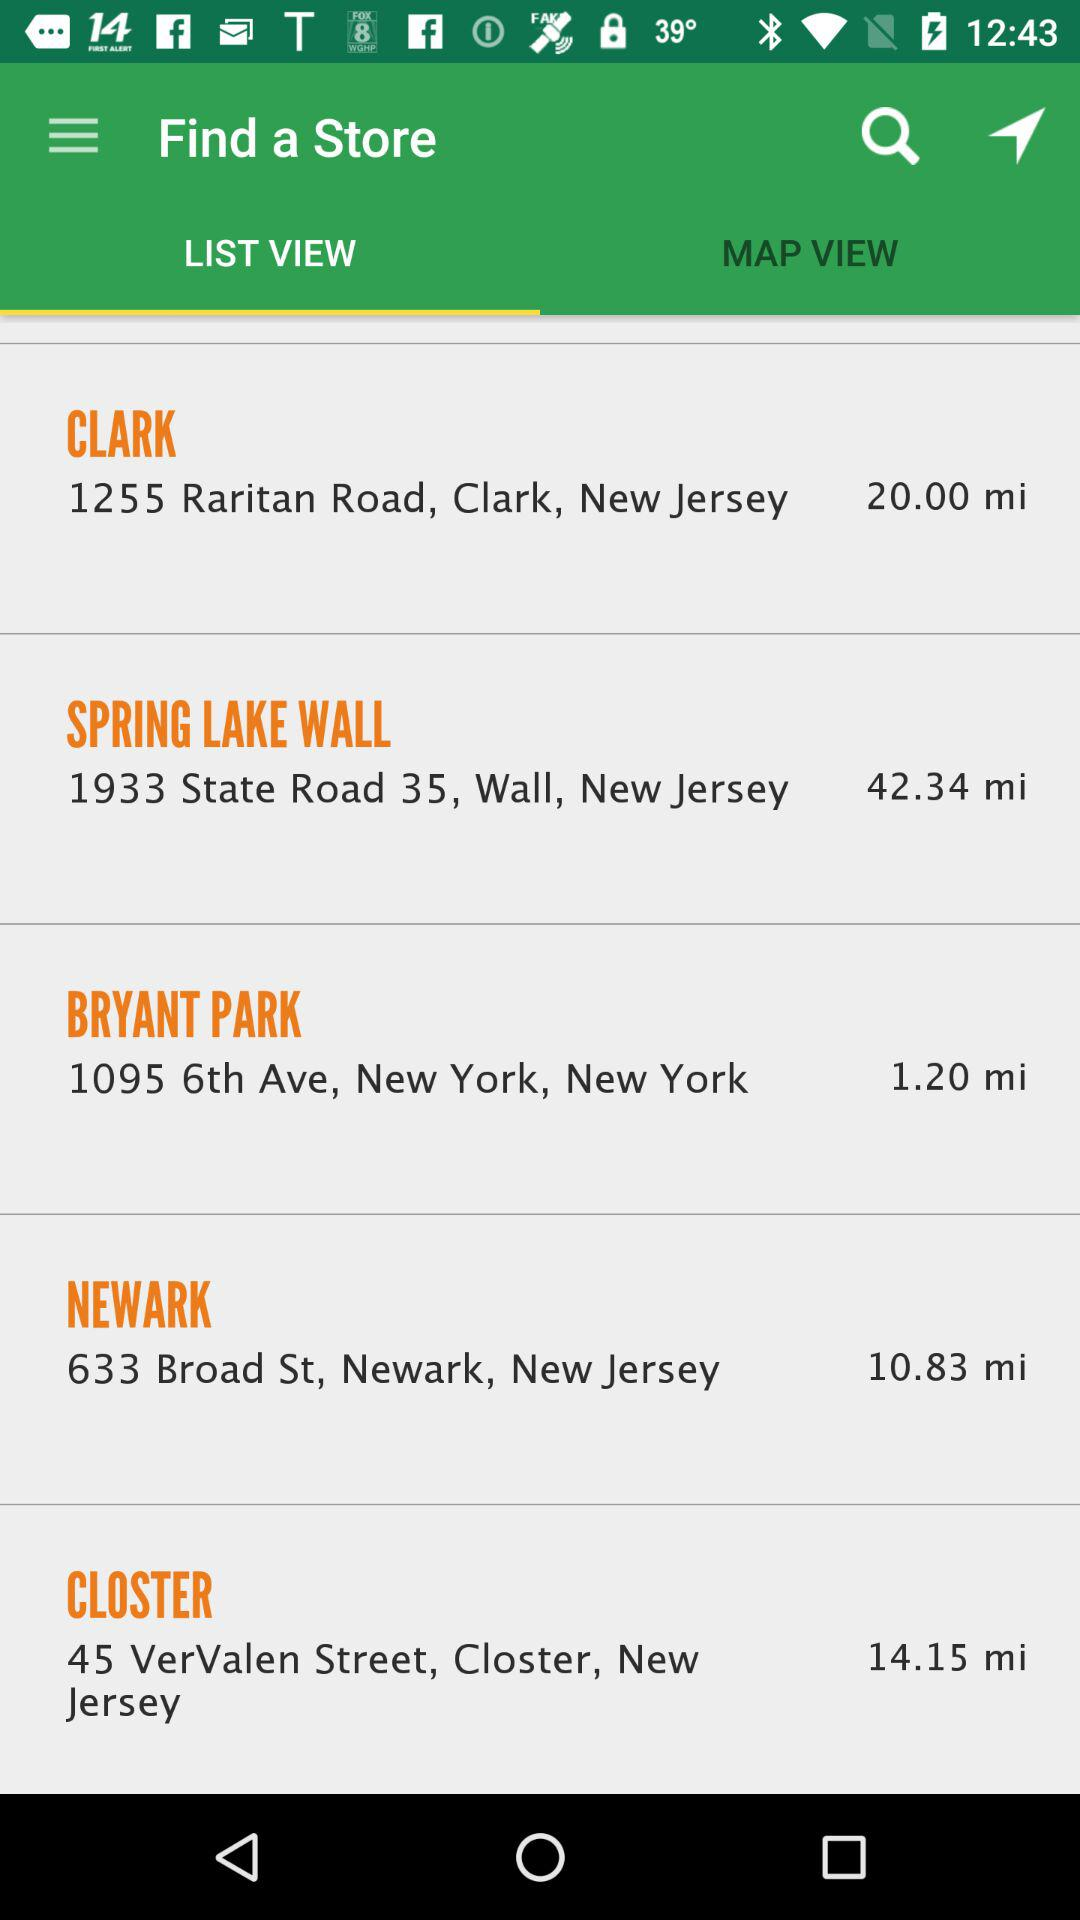Which are the different stores? The different stores are Clark, Spring Lake Wall, Bryant Park, Newark and Closter. 